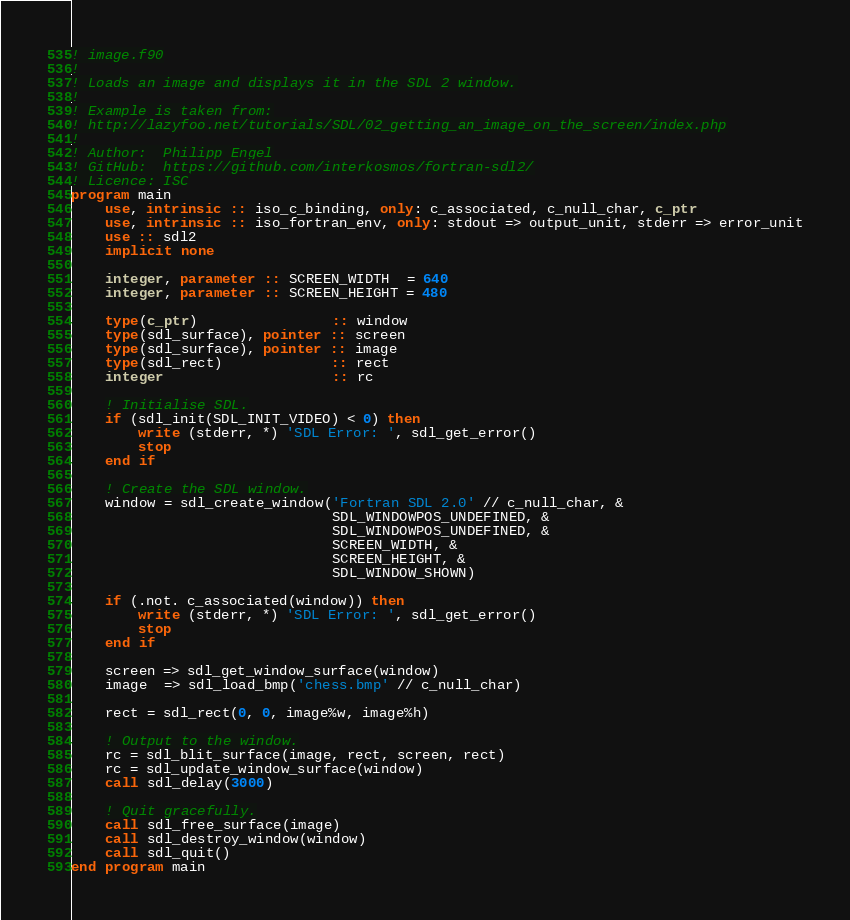Convert code to text. <code><loc_0><loc_0><loc_500><loc_500><_FORTRAN_>! image.f90
!
! Loads an image and displays it in the SDL 2 window.
!
! Example is taken from:
! http://lazyfoo.net/tutorials/SDL/02_getting_an_image_on_the_screen/index.php
!
! Author:  Philipp Engel
! GitHub:  https://github.com/interkosmos/fortran-sdl2/
! Licence: ISC
program main
    use, intrinsic :: iso_c_binding, only: c_associated, c_null_char, c_ptr
    use, intrinsic :: iso_fortran_env, only: stdout => output_unit, stderr => error_unit
    use :: sdl2
    implicit none

    integer, parameter :: SCREEN_WIDTH  = 640
    integer, parameter :: SCREEN_HEIGHT = 480

    type(c_ptr)                :: window
    type(sdl_surface), pointer :: screen
    type(sdl_surface), pointer :: image
    type(sdl_rect)             :: rect
    integer                    :: rc

    ! Initialise SDL.
    if (sdl_init(SDL_INIT_VIDEO) < 0) then
        write (stderr, *) 'SDL Error: ', sdl_get_error()
        stop
    end if

    ! Create the SDL window.
    window = sdl_create_window('Fortran SDL 2.0' // c_null_char, &
                               SDL_WINDOWPOS_UNDEFINED, &
                               SDL_WINDOWPOS_UNDEFINED, &
                               SCREEN_WIDTH, &
                               SCREEN_HEIGHT, &
                               SDL_WINDOW_SHOWN)

    if (.not. c_associated(window)) then
        write (stderr, *) 'SDL Error: ', sdl_get_error()
        stop
    end if

    screen => sdl_get_window_surface(window)
    image  => sdl_load_bmp('chess.bmp' // c_null_char)

    rect = sdl_rect(0, 0, image%w, image%h)

    ! Output to the window.
    rc = sdl_blit_surface(image, rect, screen, rect)
    rc = sdl_update_window_surface(window)
    call sdl_delay(3000)

    ! Quit gracefully.
    call sdl_free_surface(image)
    call sdl_destroy_window(window)
    call sdl_quit()
end program main
</code> 